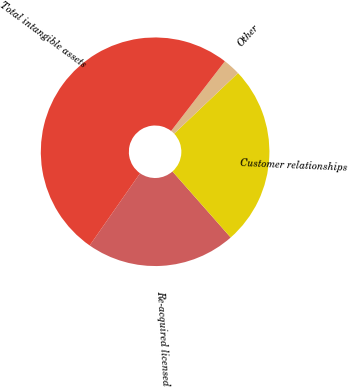<chart> <loc_0><loc_0><loc_500><loc_500><pie_chart><fcel>Re-acquired licensed<fcel>Customer relationships<fcel>Other<fcel>Total intangible assets<nl><fcel>21.2%<fcel>25.59%<fcel>2.46%<fcel>50.76%<nl></chart> 